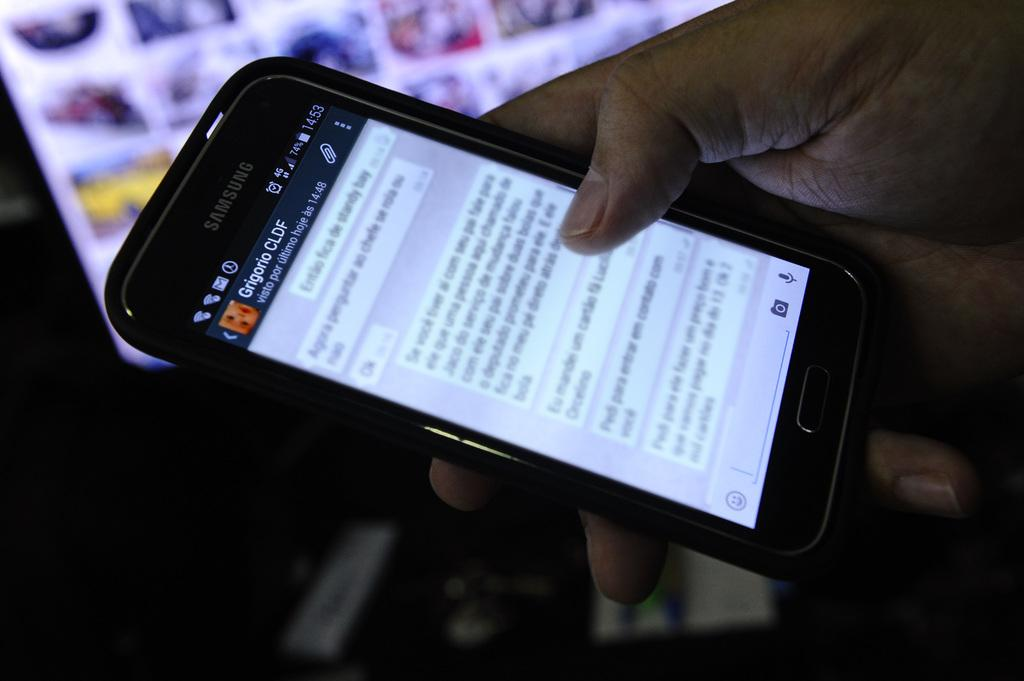<image>
Present a compact description of the photo's key features. The screen of a cell phone showing a series of text messages with gregorio CLDF. 